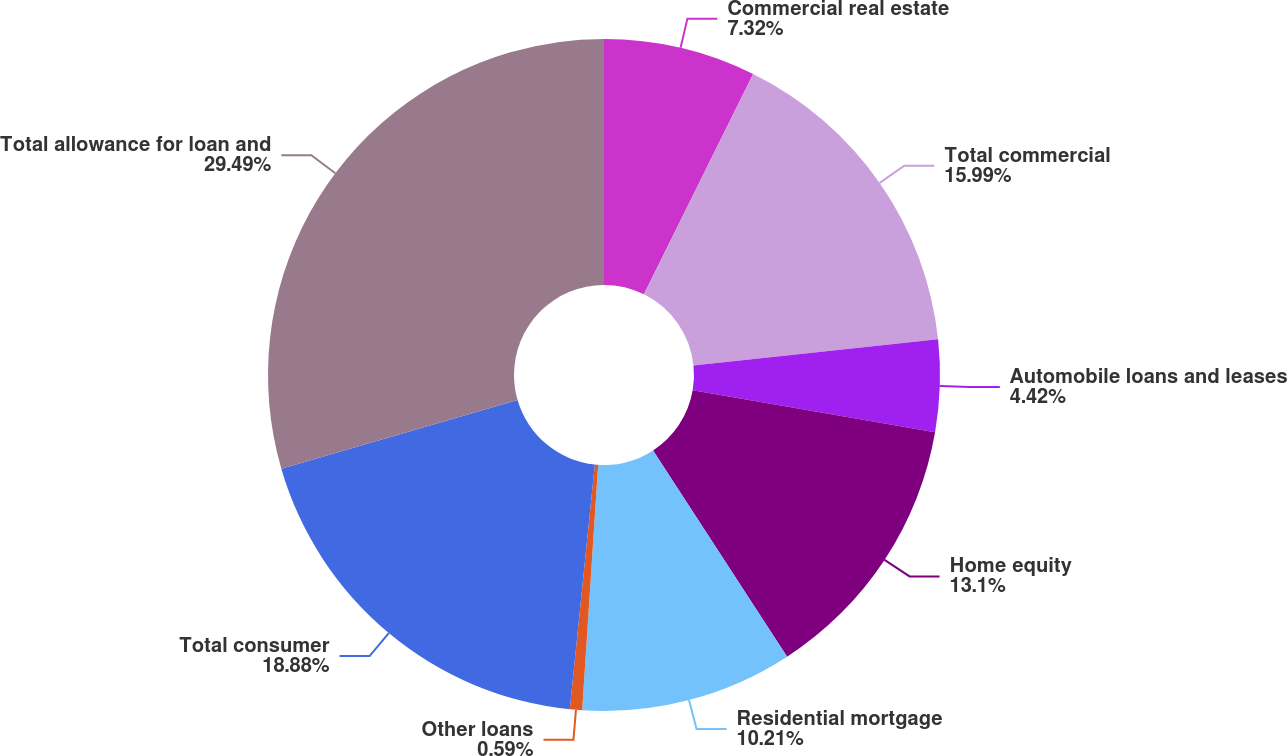Convert chart. <chart><loc_0><loc_0><loc_500><loc_500><pie_chart><fcel>Commercial real estate<fcel>Total commercial<fcel>Automobile loans and leases<fcel>Home equity<fcel>Residential mortgage<fcel>Other loans<fcel>Total consumer<fcel>Total allowance for loan and<nl><fcel>7.32%<fcel>15.99%<fcel>4.42%<fcel>13.1%<fcel>10.21%<fcel>0.59%<fcel>18.88%<fcel>29.5%<nl></chart> 